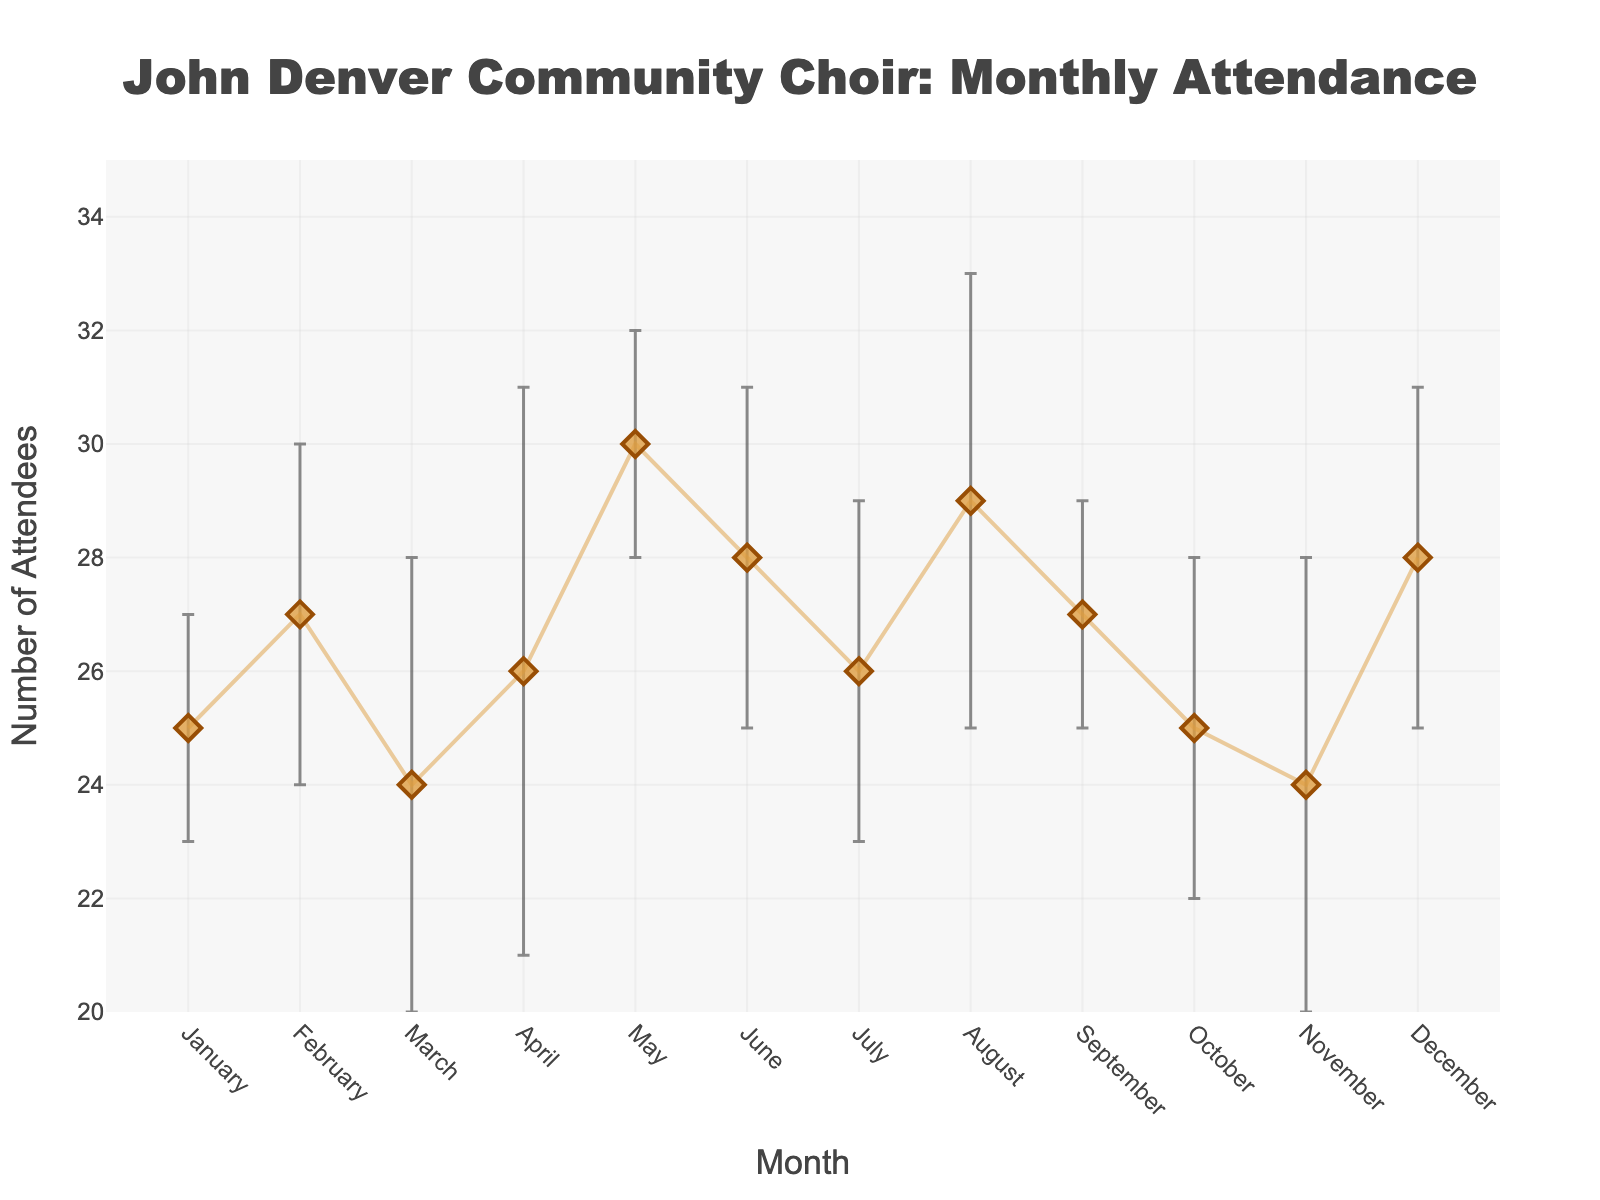How many months are plotted in the figure? There are labels for each month from January to December on the x-axis. Counting these, we get 12 months.
Answer: 12 What's the general trend in the average attendance throughout the year? By observing the line in the plot, we see fluctuations in attendance but no definitive upward or downward trend throughout the year.
Answer: Fluctuates Which month has the highest average attendance? From the figure, the highest point on the y-axis corresponds to May with an average attendance value of 30.
Answer: May Which month has the lowest average attendance? The lowest point on the y-axis corresponds to March and November, both with an average attendance of 24.
Answer: March and November What is the difference between the highest and lowest average attendance? The highest average attendance is 30 (May) and the lowest is 24 (March, November). The difference is 30 - 24 = 6.
Answer: 6 In which month is the standard deviation of attendance the highest? The error bars show the standard deviation, and the longest error bar is in April which represents a standard deviation of 5.
Answer: April What is the sum of average attendances in the first quarter of the year? Summing the average attendance values for January (25), February (27), and March (24): 25 + 27 + 24 = 76.
Answer: 76 Which months have the average attendance exactly equal to 28? By checking the y-values in the plot, June, August, and December have an average attendance of 28.
Answer: June, August, December Which months have an average attendance less than 25? From the plot, only March and November have average attendances below 25.
Answer: March and November What is the average of the standard deviation values over the entire year? Sum of standard deviations: 2 + 3 + 4 + 5 + 2 + 3 + 3 + 4 + 2 + 3 + 4 + 3 = 38. There are 12 months, so 38 / 12 = 3.17.
Answer: 3.17 